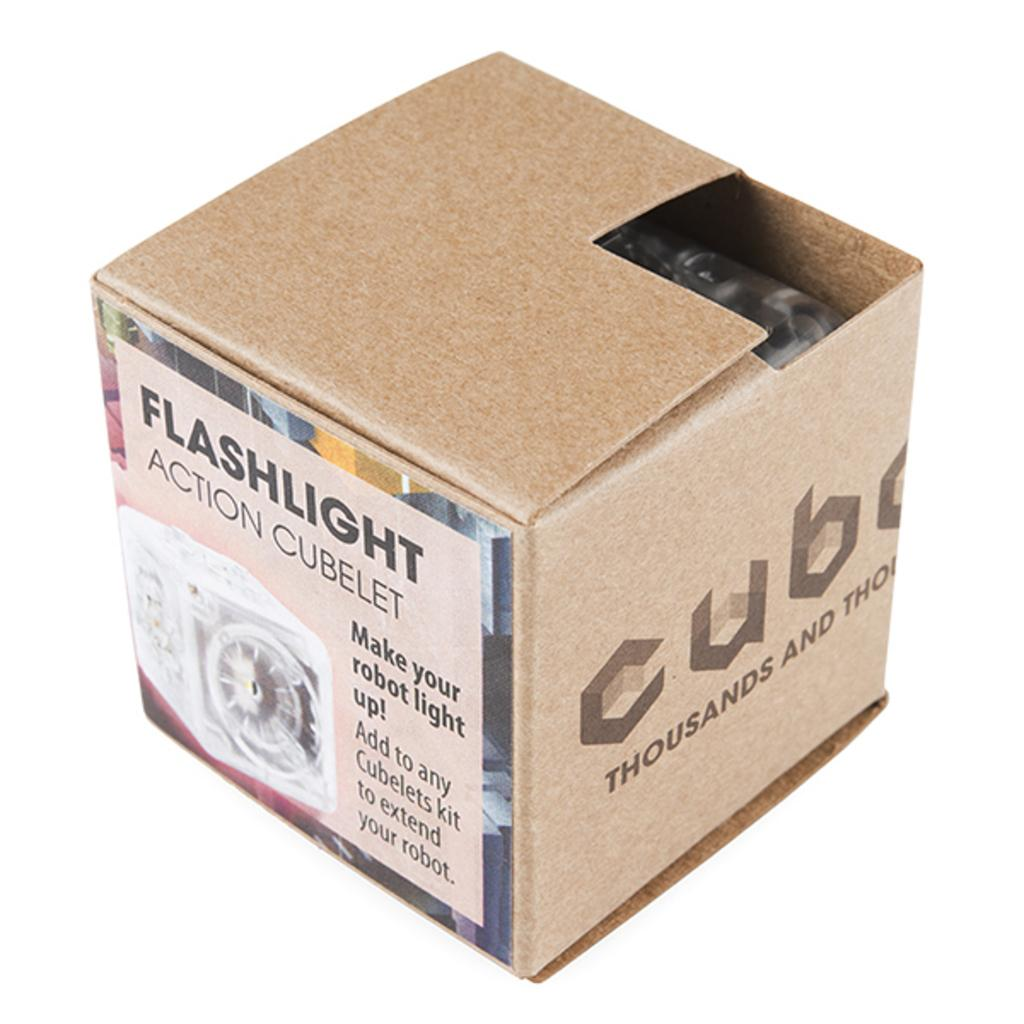<image>
Share a concise interpretation of the image provided. A box with a label for a flashlight on the side is partially open. 